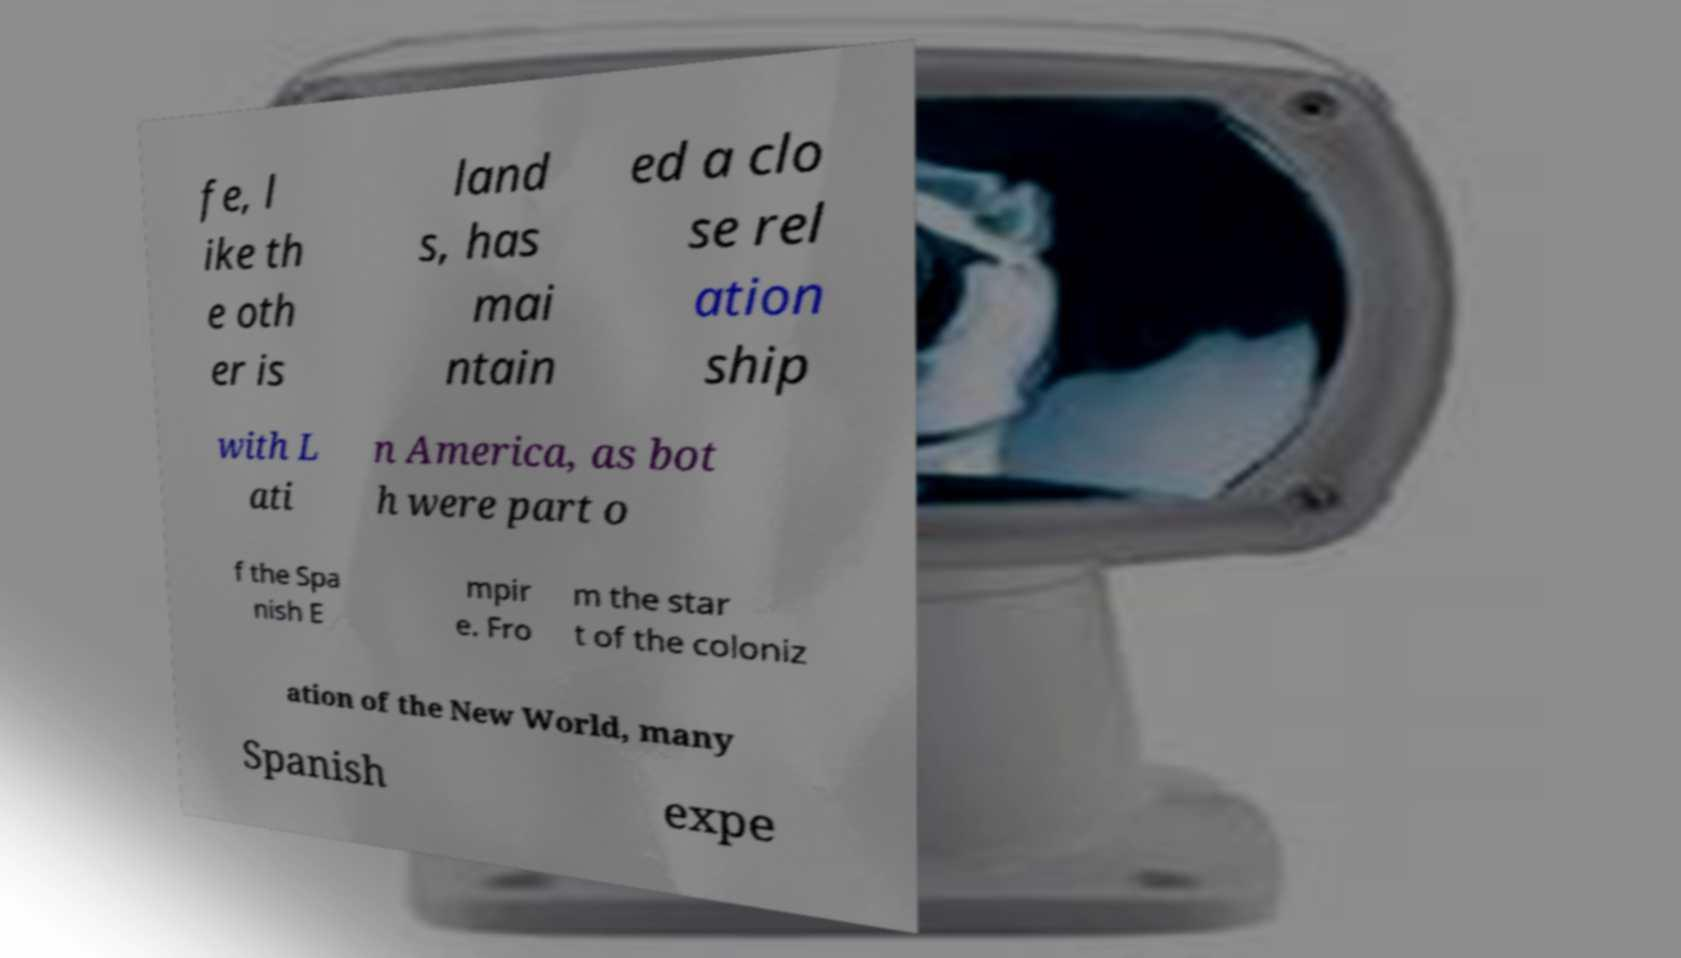For documentation purposes, I need the text within this image transcribed. Could you provide that? fe, l ike th e oth er is land s, has mai ntain ed a clo se rel ation ship with L ati n America, as bot h were part o f the Spa nish E mpir e. Fro m the star t of the coloniz ation of the New World, many Spanish expe 